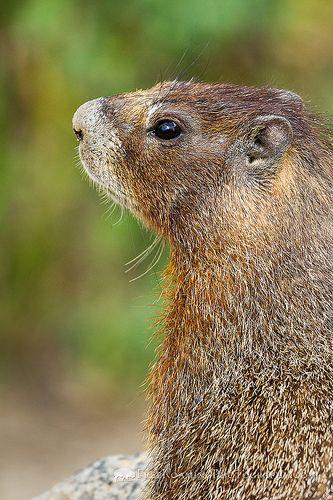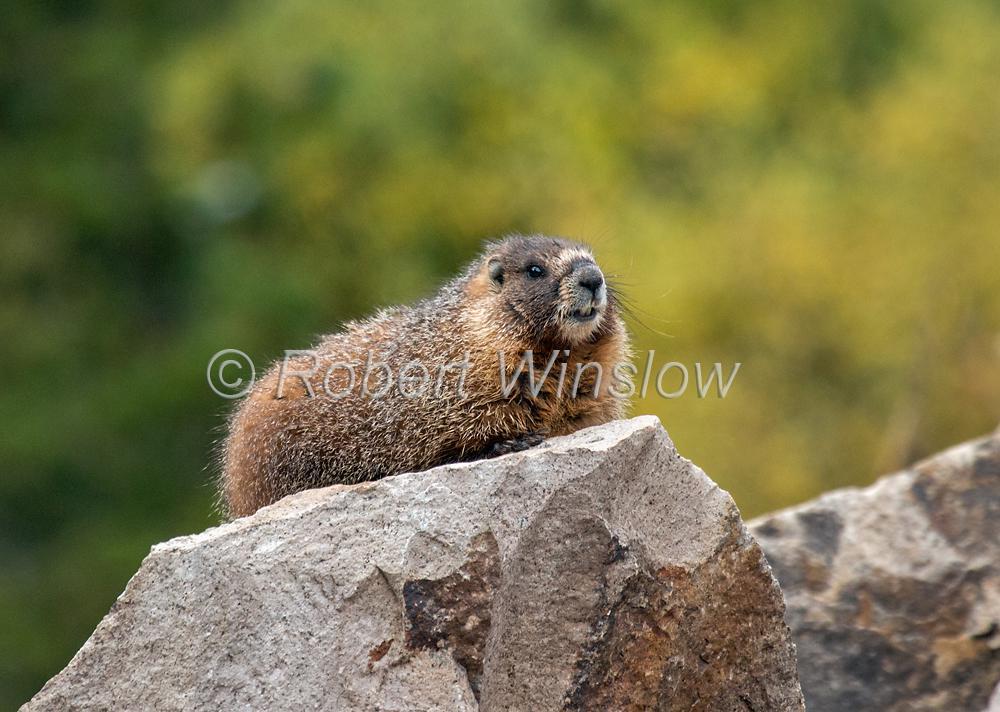The first image is the image on the left, the second image is the image on the right. Evaluate the accuracy of this statement regarding the images: "There are more than two animals total.". Is it true? Answer yes or no. No. 